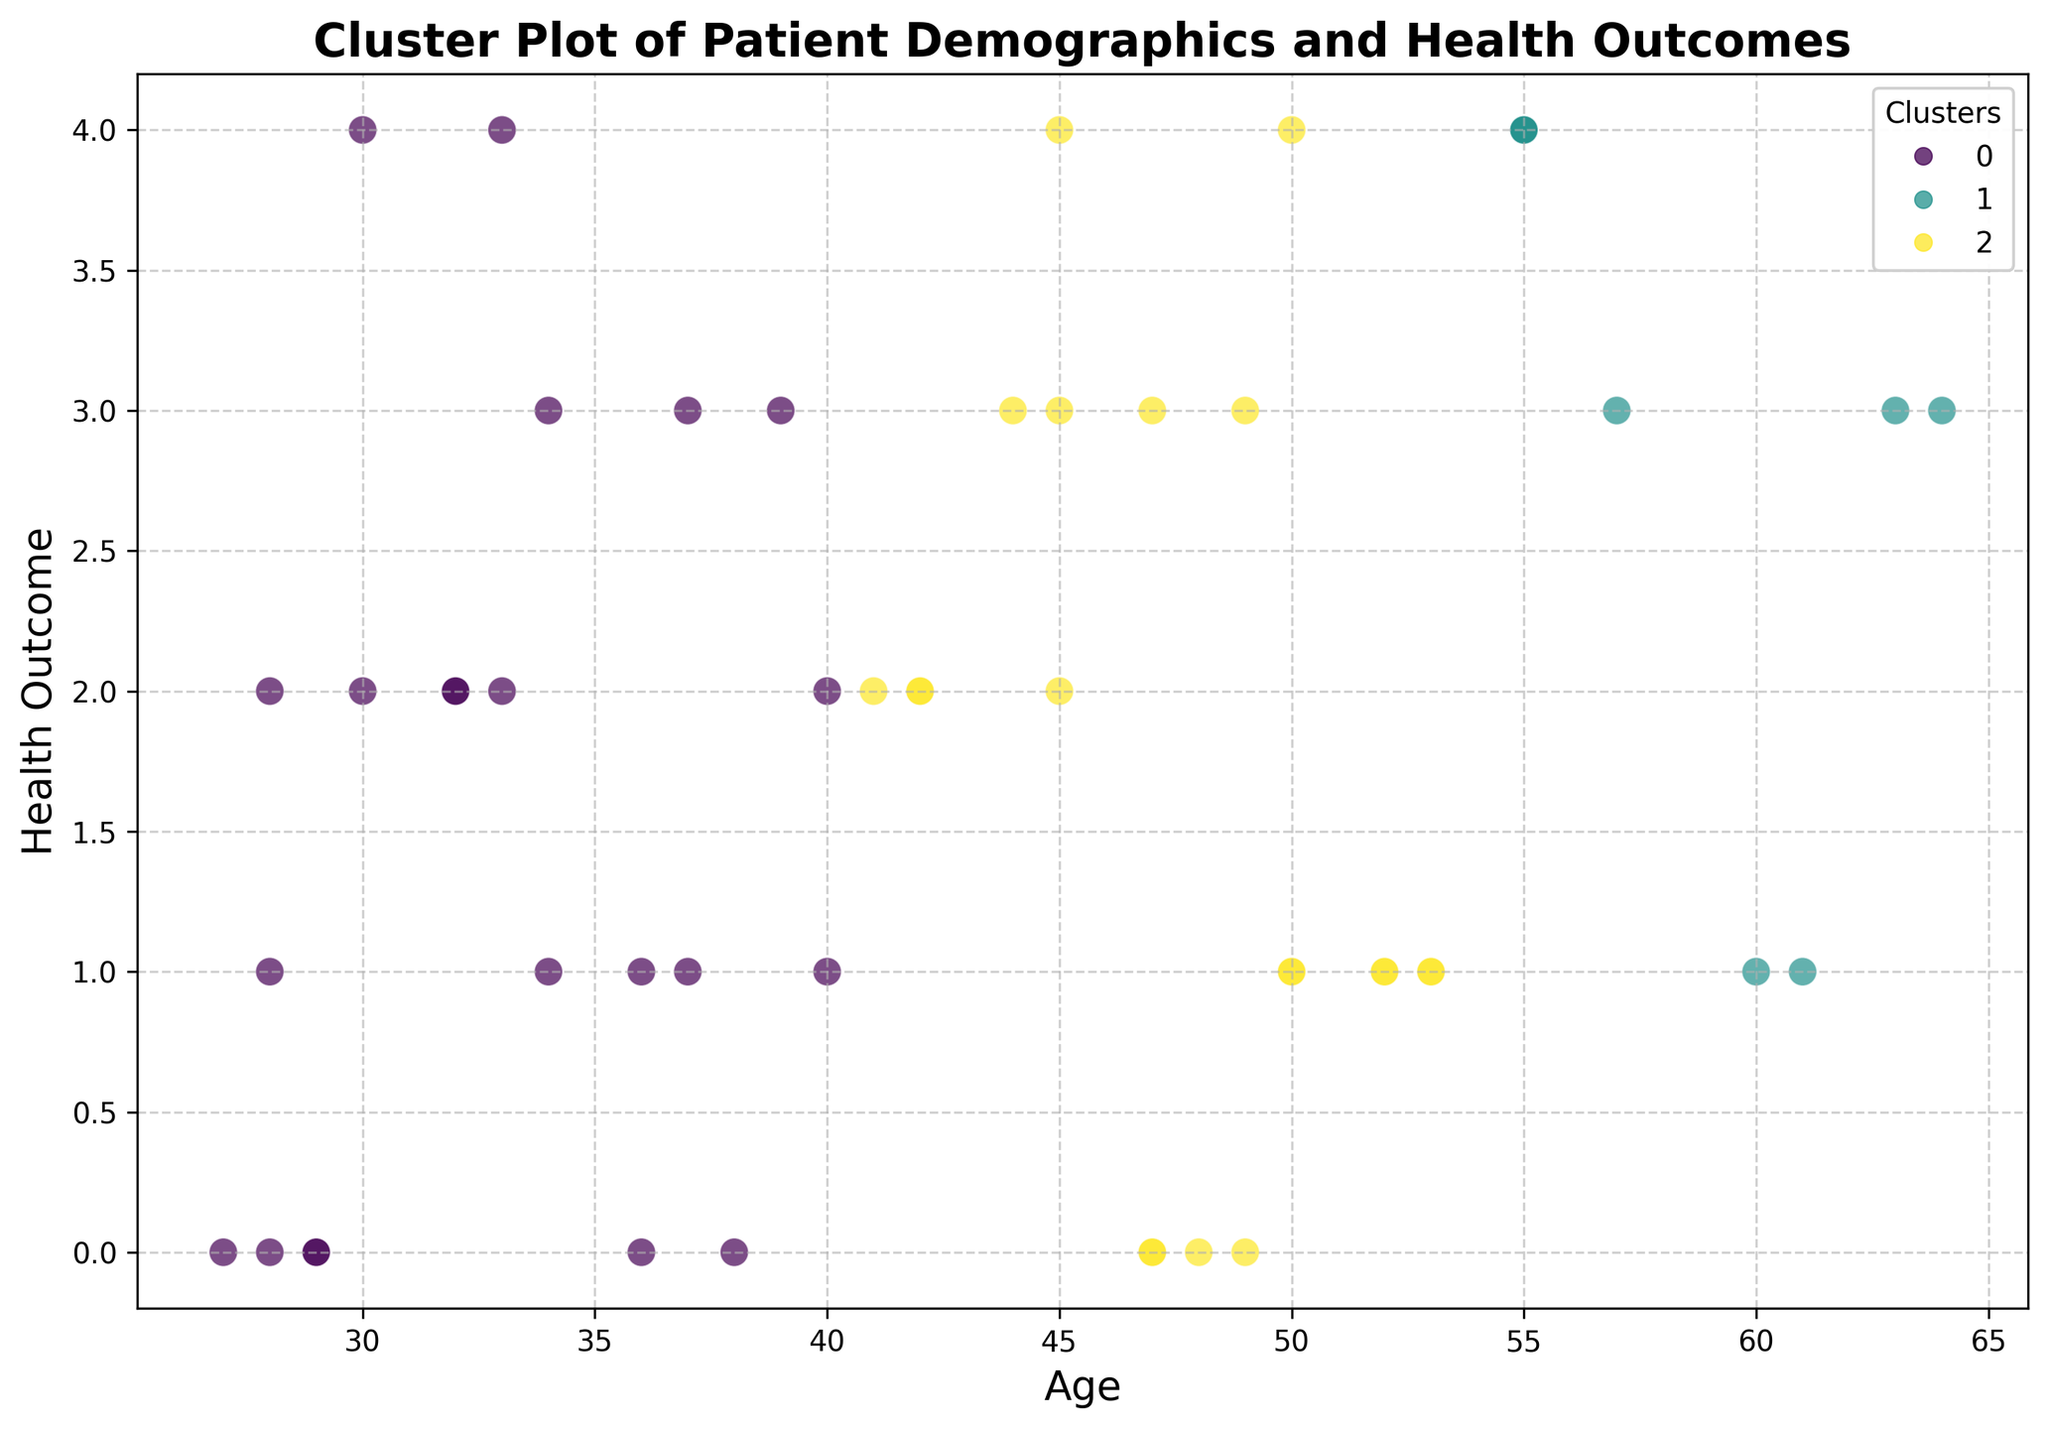Which cluster contains the oldest patient? By examining the scatter plot, identify the patient with the highest age value and check their cluster color in the legend.
Answer: Cluster X (replace "X" with the exact cluster from the plot) Which cluster has the most patients with a "Very Poor" health outcome? Count the number of data points within the cluster that are positioned at the "Very Poor" health outcome level on the y-axis and compare among clusters.
Answer: Cluster Y (replace "Y" with the exact cluster from the plot) Are younger patients more likely to be in a specific cluster? Observe the age distribution of data points across clusters and see if younger patients predominantly belong to one cluster. Younger patients will be data points towards the left of the x-axis.
Answer: Yes, in Cluster Z (replace "Z" with the exact cluster from the plot, if applicable) Which cluster has the patients with the highest health outcomes? Look for the cluster that has the most data points situated at the highest values on the health outcome axis.
Answer: Cluster W (replace "W" with the exact cluster from the plot) How does the distribution of health outcomes vary across clusters? Investigate the y-axis positions of data points within each cluster, noting whether they are concentrated at high or low health outcome values.
Answer: Clusters A and B have higher outcomes, while Cluster C has lower outcomes (replace clusters as per plot) Is there a cluster that has a balanced representation across different ages? Check if any cluster has data points evenly spread out along the age axis, without a particular concentration in one age group.
Answer: Yes, Cluster V (replace "V" with the exact cluster from the plot, if applicable) Which cluster appears to have the greatest variation in age? Observe the range of ages within each cluster and identify the one with the widest spread of data points along the age axis.
Answer: Cluster U (replace "U" with the exact cluster from the plot) Do older patients tend to have better or worse health outcomes based on their cluster? Compare the age and health outcome positions for older patients across clusters to determine if there's a trend. Older patients will be data points towards the right of the x-axis.
Answer: Generally better in Cluster T (replace "T" with the exact cluster from the plot, if applicable) How do the clusters differ in terms of the density of data points? Analyze the scatter plot to see how tightly packed the data points are within each cluster, indicating density.
Answer: Cluster S has the highest density (replace “S” with the exact cluster from the plot) Is there any visible trend in health outcomes with respect to age within each cluster? For each cluster, observe if there's a pattern where age correlates with health outcomes by looking at the spread of points along both axes.
Answer: Yes, older patients in Cluster R tend to have better outcomes (replace “R” with the exact cluster from the plot, if applicable) 